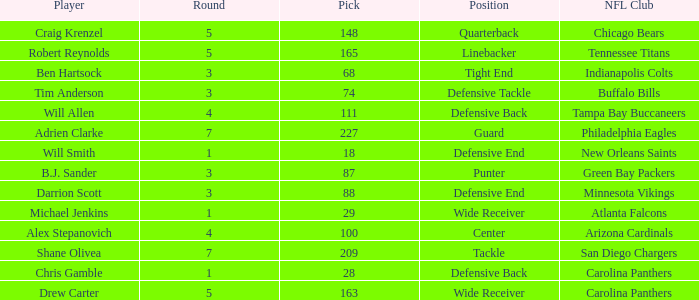What is the average Round number of Player Adrien Clarke? 7.0. 